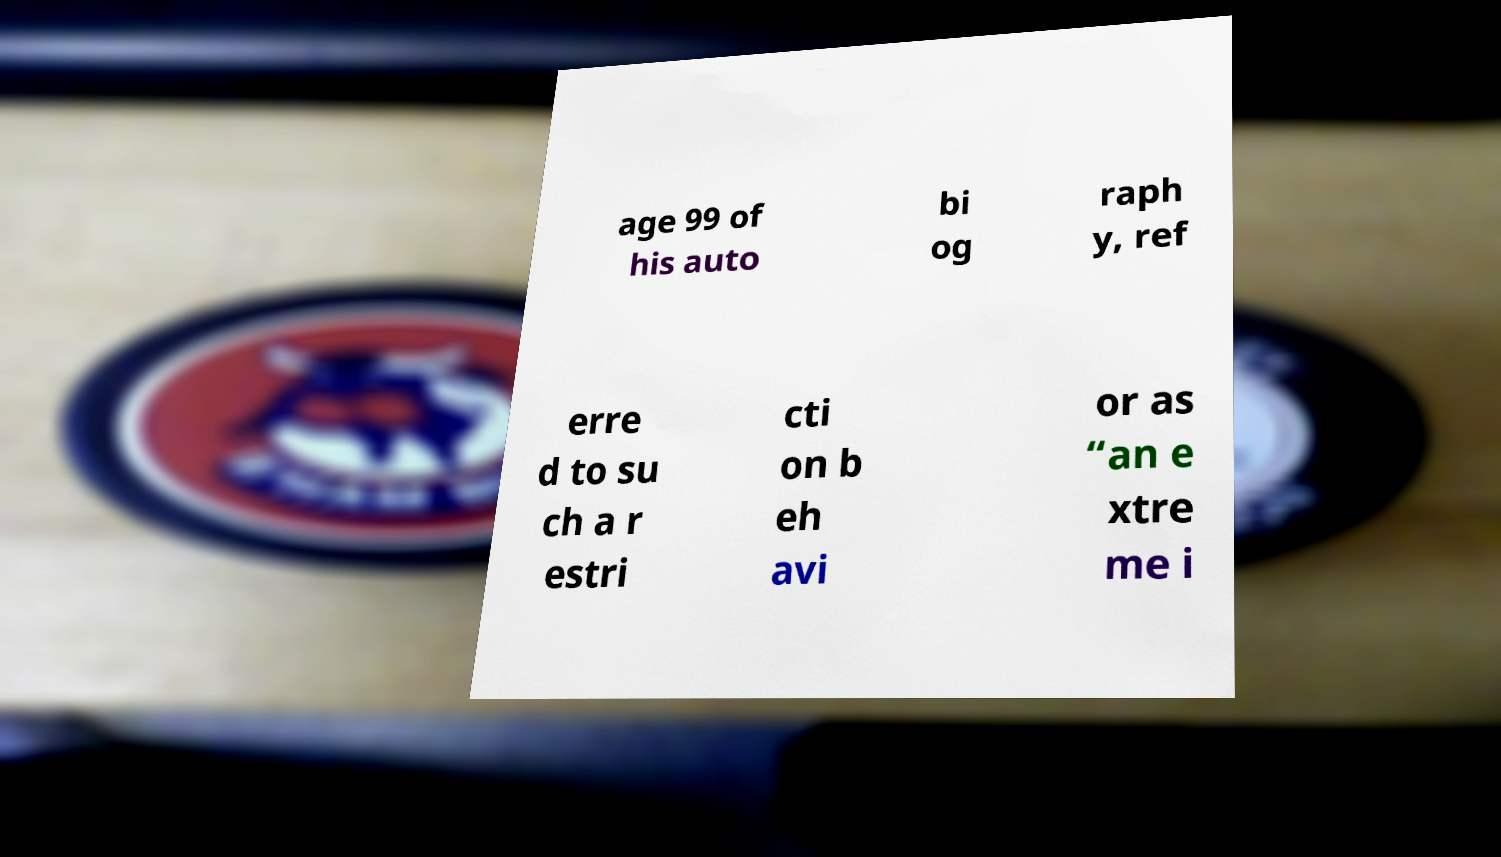Can you read and provide the text displayed in the image?This photo seems to have some interesting text. Can you extract and type it out for me? age 99 of his auto bi og raph y, ref erre d to su ch a r estri cti on b eh avi or as “an e xtre me i 